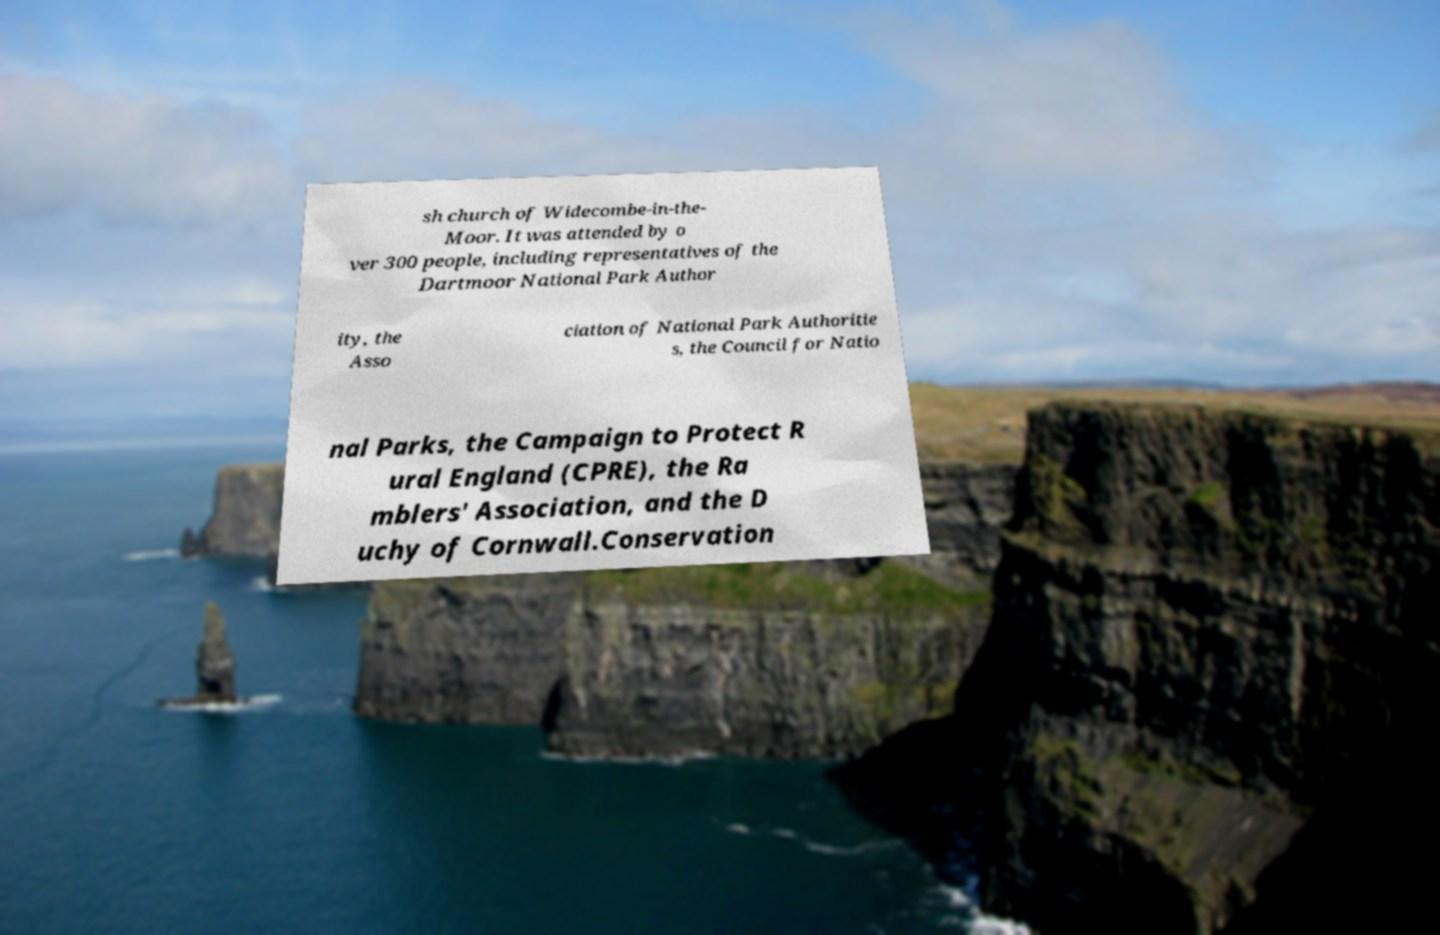Could you extract and type out the text from this image? sh church of Widecombe-in-the- Moor. It was attended by o ver 300 people, including representatives of the Dartmoor National Park Author ity, the Asso ciation of National Park Authoritie s, the Council for Natio nal Parks, the Campaign to Protect R ural England (CPRE), the Ra mblers' Association, and the D uchy of Cornwall.Conservation 